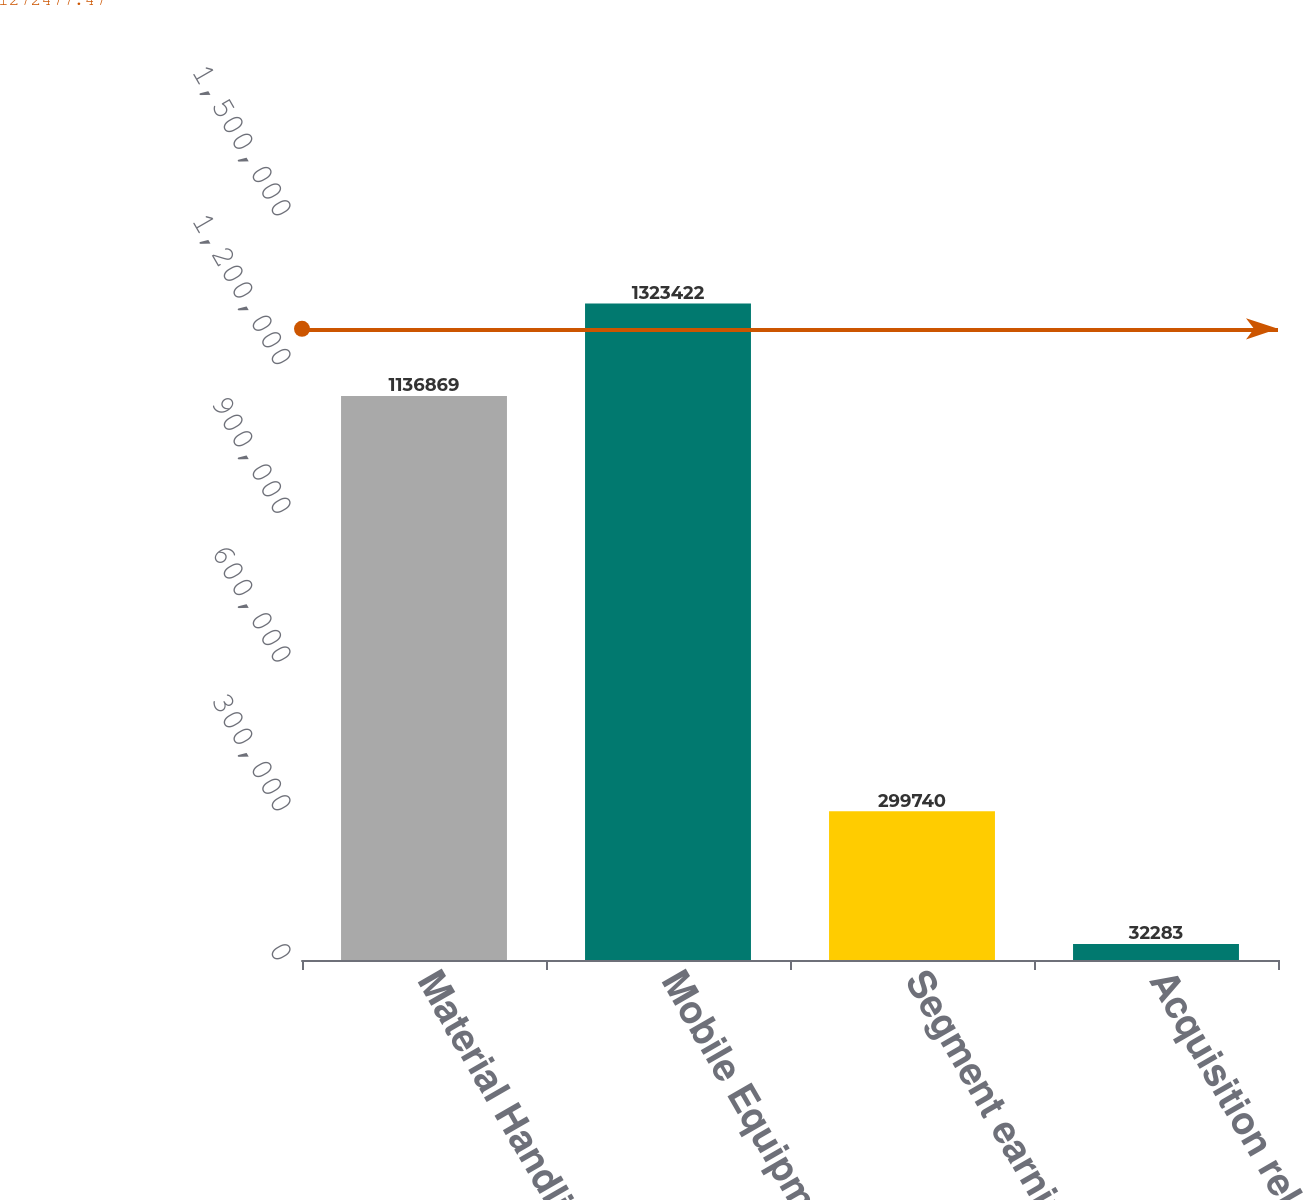Convert chart to OTSL. <chart><loc_0><loc_0><loc_500><loc_500><bar_chart><fcel>Material Handling<fcel>Mobile Equipment<fcel>Segment earnings<fcel>Acquisition related<nl><fcel>1.13687e+06<fcel>1.32342e+06<fcel>299740<fcel>32283<nl></chart> 